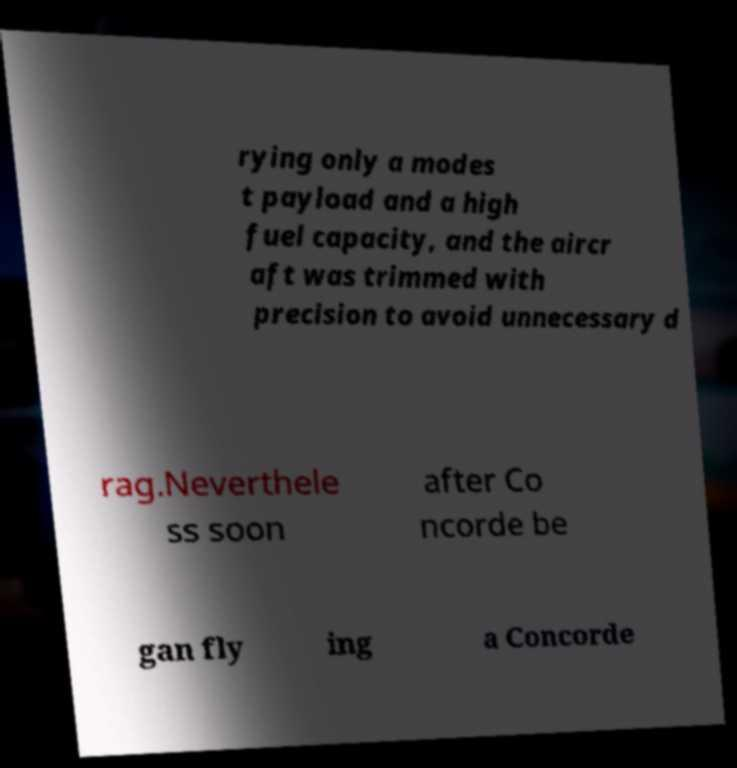For documentation purposes, I need the text within this image transcribed. Could you provide that? rying only a modes t payload and a high fuel capacity, and the aircr aft was trimmed with precision to avoid unnecessary d rag.Neverthele ss soon after Co ncorde be gan fly ing a Concorde 